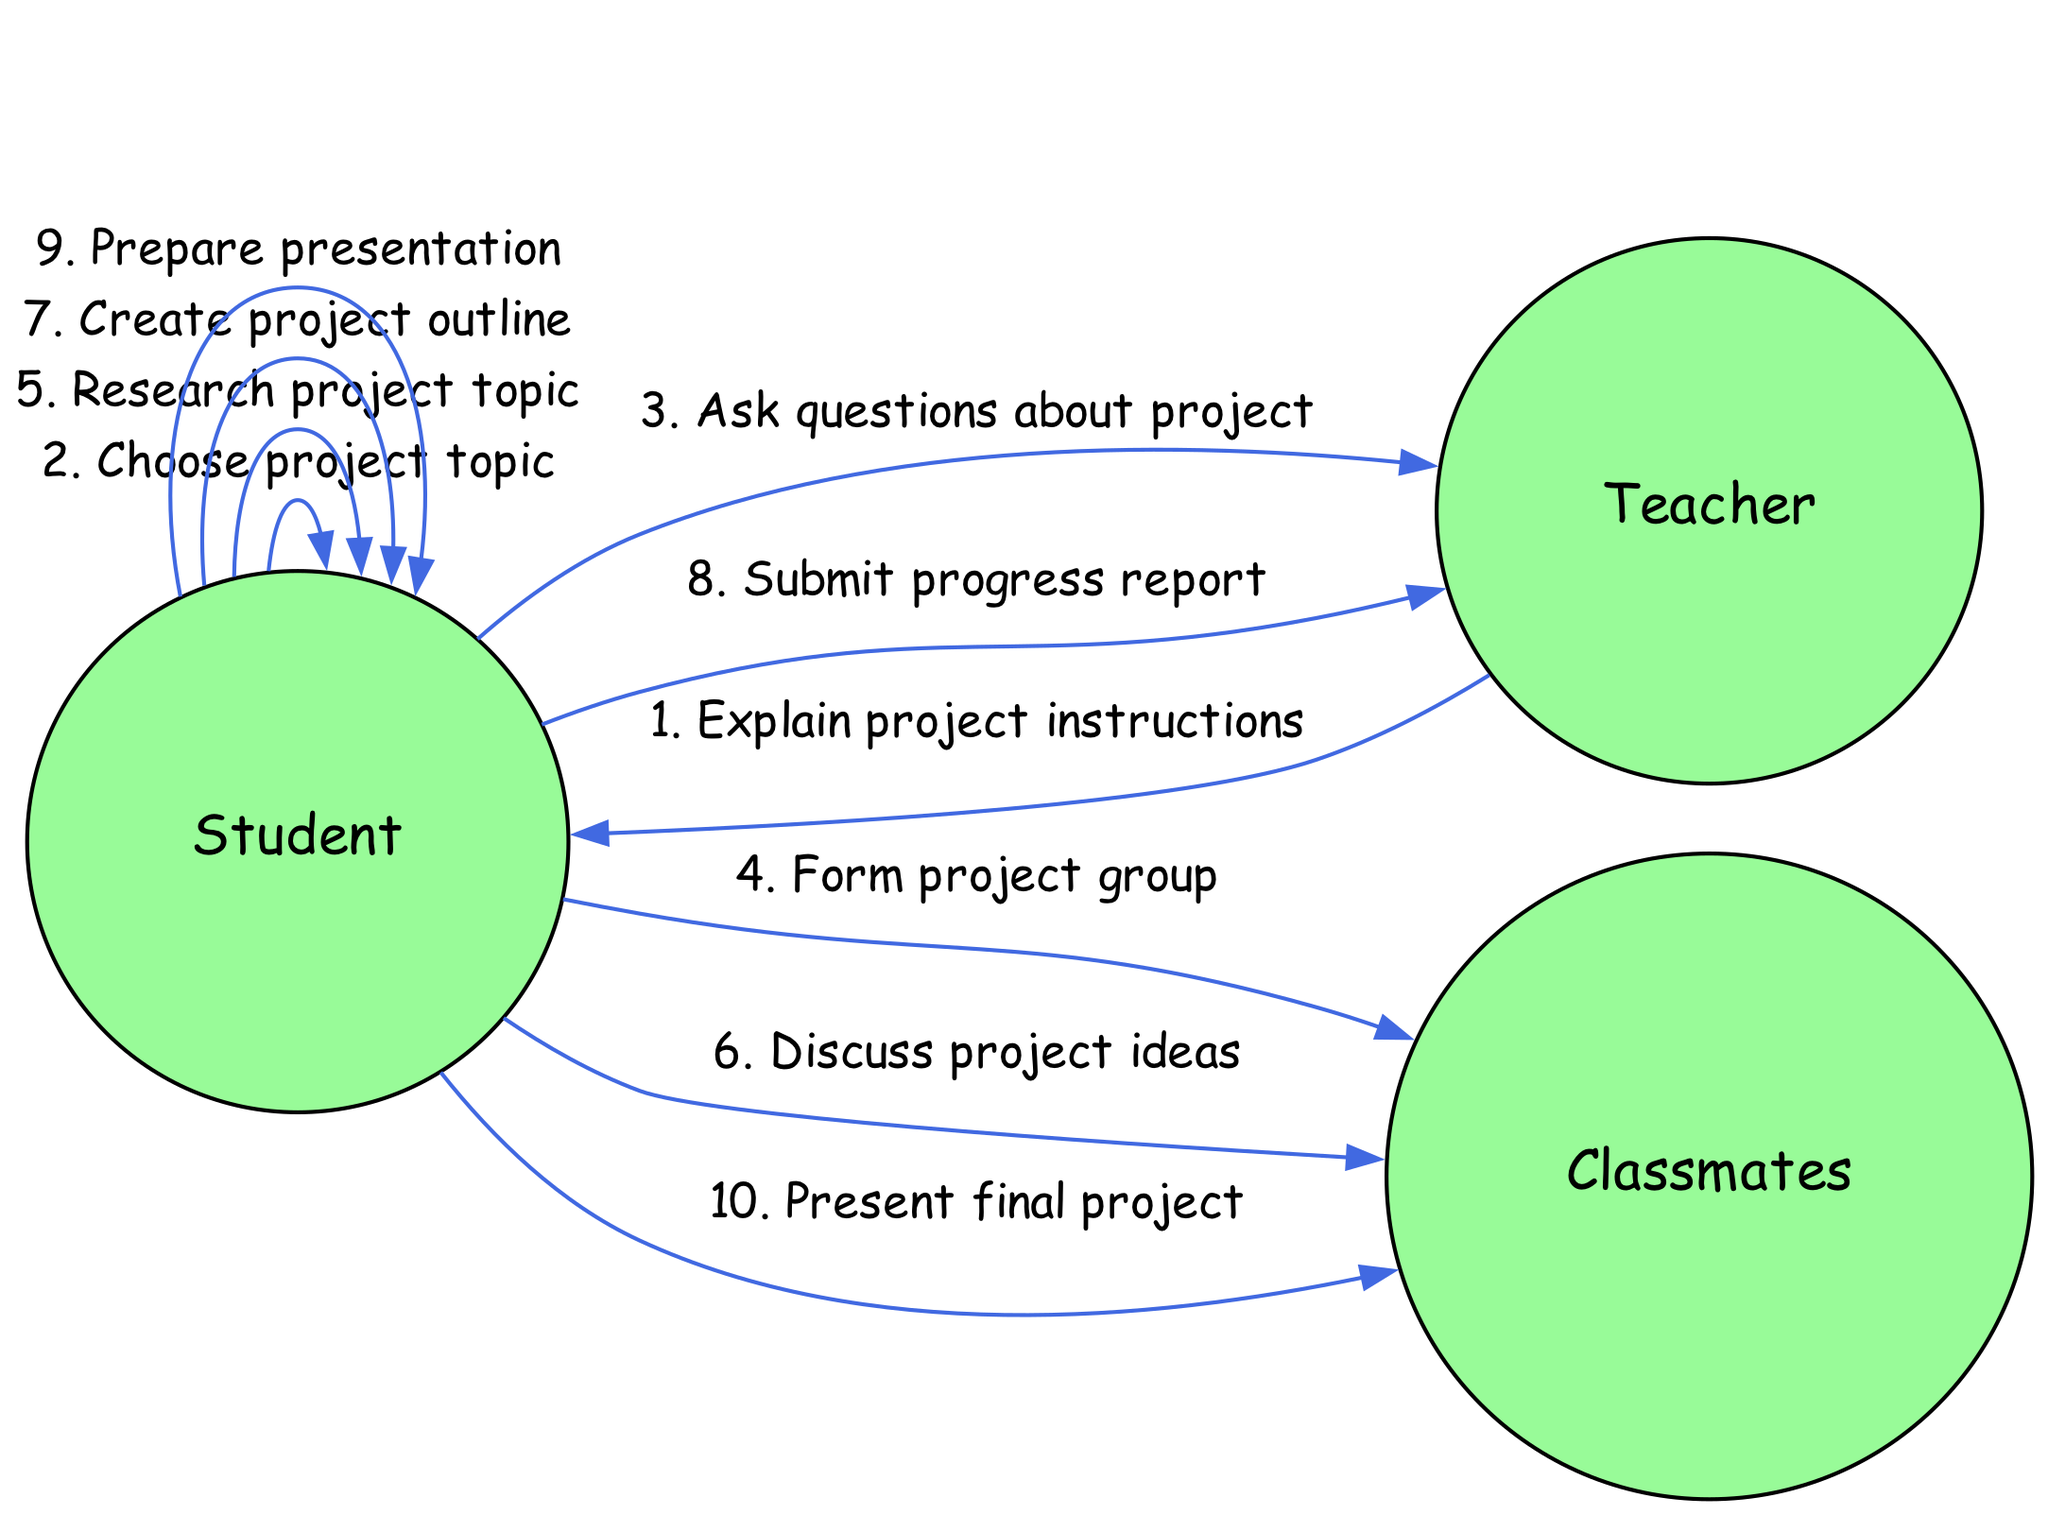What does the teacher first do in the project sequence? The first action in the diagram shows the Teacher explaining the project instructions to the Student. This is the starting point of the sequence.
Answer: Explain project instructions How many actors are involved in the project sequence? The diagram includes three actors: Teacher, Student, and Classmates. Counting these gives a total of three actors involved.
Answer: Three What does the student do after choosing the project topic? According to the sequence, after choosing the project topic, the Student then asks questions about the project to the Teacher. This shows the natural progression of actions.
Answer: Ask questions about project Which action comes directly before the Student submits the progress report? Before the Student submits the progress report, the action that comes directly before this step is the Student creating the project outline. This means there is a flow from creating an outline to submitting the report.
Answer: Create project outline What is the last action listed in the sequence? The last action mentioned at the end of the sequence is the Student presenting the final project to the Classmates. This is the concluding step of the project involvement sequence.
Answer: Present final project How many actions does the Student perform in total? By counting all the actions associated with the Student from the sequence, there are five distinct actions taken by the Student throughout the project process.
Answer: Five Who does the Student discuss project ideas with? The Student discusses project ideas with their Classmates. This is explicitly stated in the sequence, indicating collaboration among peers.
Answer: Classmates What step occurs right after the Student prepares the presentation? Following the preparation of the presentation, the next step is for the Student to present the final project to the Classmates. This demonstrates a clear transition from preparation to presentation.
Answer: Present final project 